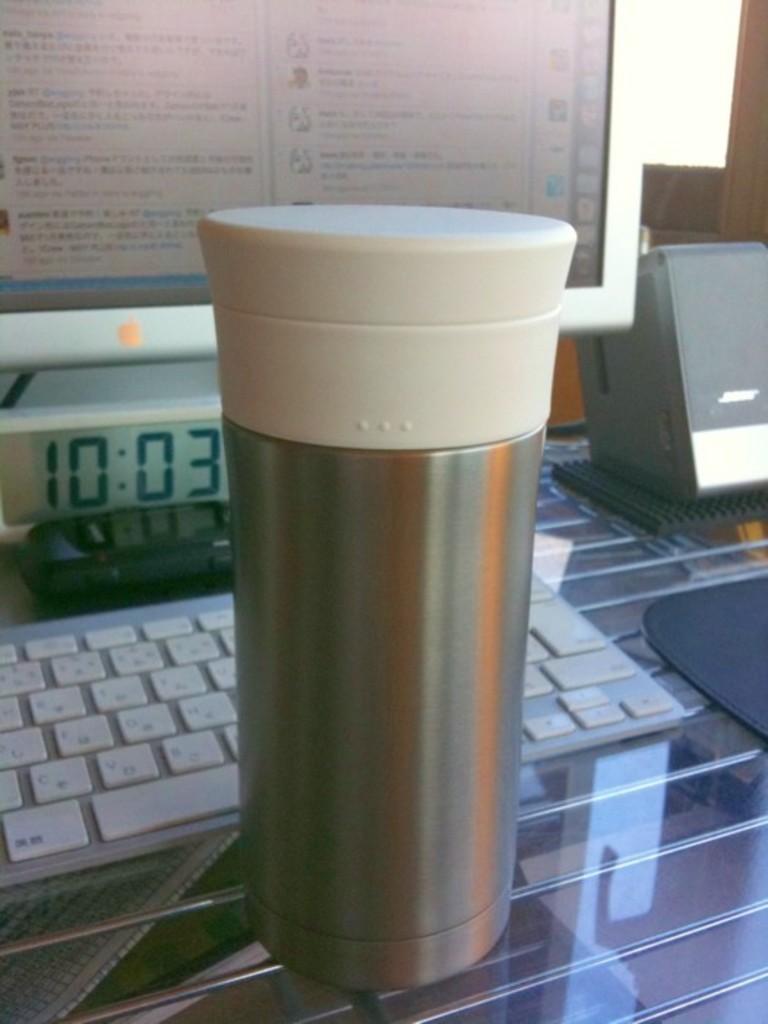What time was it here?
Offer a very short reply. 10:03. 